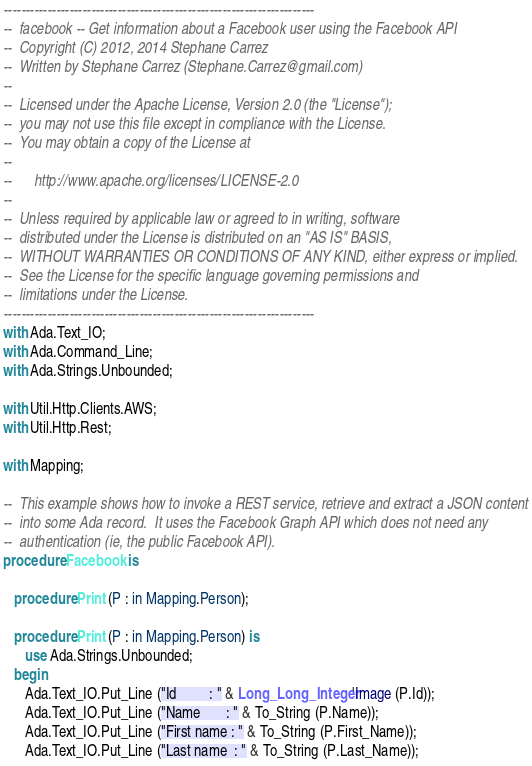<code> <loc_0><loc_0><loc_500><loc_500><_Ada_>-----------------------------------------------------------------------
--  facebook -- Get information about a Facebook user using the Facebook API
--  Copyright (C) 2012, 2014 Stephane Carrez
--  Written by Stephane Carrez (Stephane.Carrez@gmail.com)
--
--  Licensed under the Apache License, Version 2.0 (the "License");
--  you may not use this file except in compliance with the License.
--  You may obtain a copy of the License at
--
--      http://www.apache.org/licenses/LICENSE-2.0
--
--  Unless required by applicable law or agreed to in writing, software
--  distributed under the License is distributed on an "AS IS" BASIS,
--  WITHOUT WARRANTIES OR CONDITIONS OF ANY KIND, either express or implied.
--  See the License for the specific language governing permissions and
--  limitations under the License.
-----------------------------------------------------------------------
with Ada.Text_IO;
with Ada.Command_Line;
with Ada.Strings.Unbounded;

with Util.Http.Clients.AWS;
with Util.Http.Rest;

with Mapping;

--  This example shows how to invoke a REST service, retrieve and extract a JSON content
--  into some Ada record.  It uses the Facebook Graph API which does not need any
--  authentication (ie, the public Facebook API).
procedure Facebook is

   procedure Print (P : in Mapping.Person);

   procedure Print (P : in Mapping.Person) is
      use Ada.Strings.Unbounded;
   begin
      Ada.Text_IO.Put_Line ("Id         : " & Long_Long_Integer'Image (P.Id));
      Ada.Text_IO.Put_Line ("Name       : " & To_String (P.Name));
      Ada.Text_IO.Put_Line ("First name : " & To_String (P.First_Name));
      Ada.Text_IO.Put_Line ("Last name  : " & To_String (P.Last_Name));</code> 